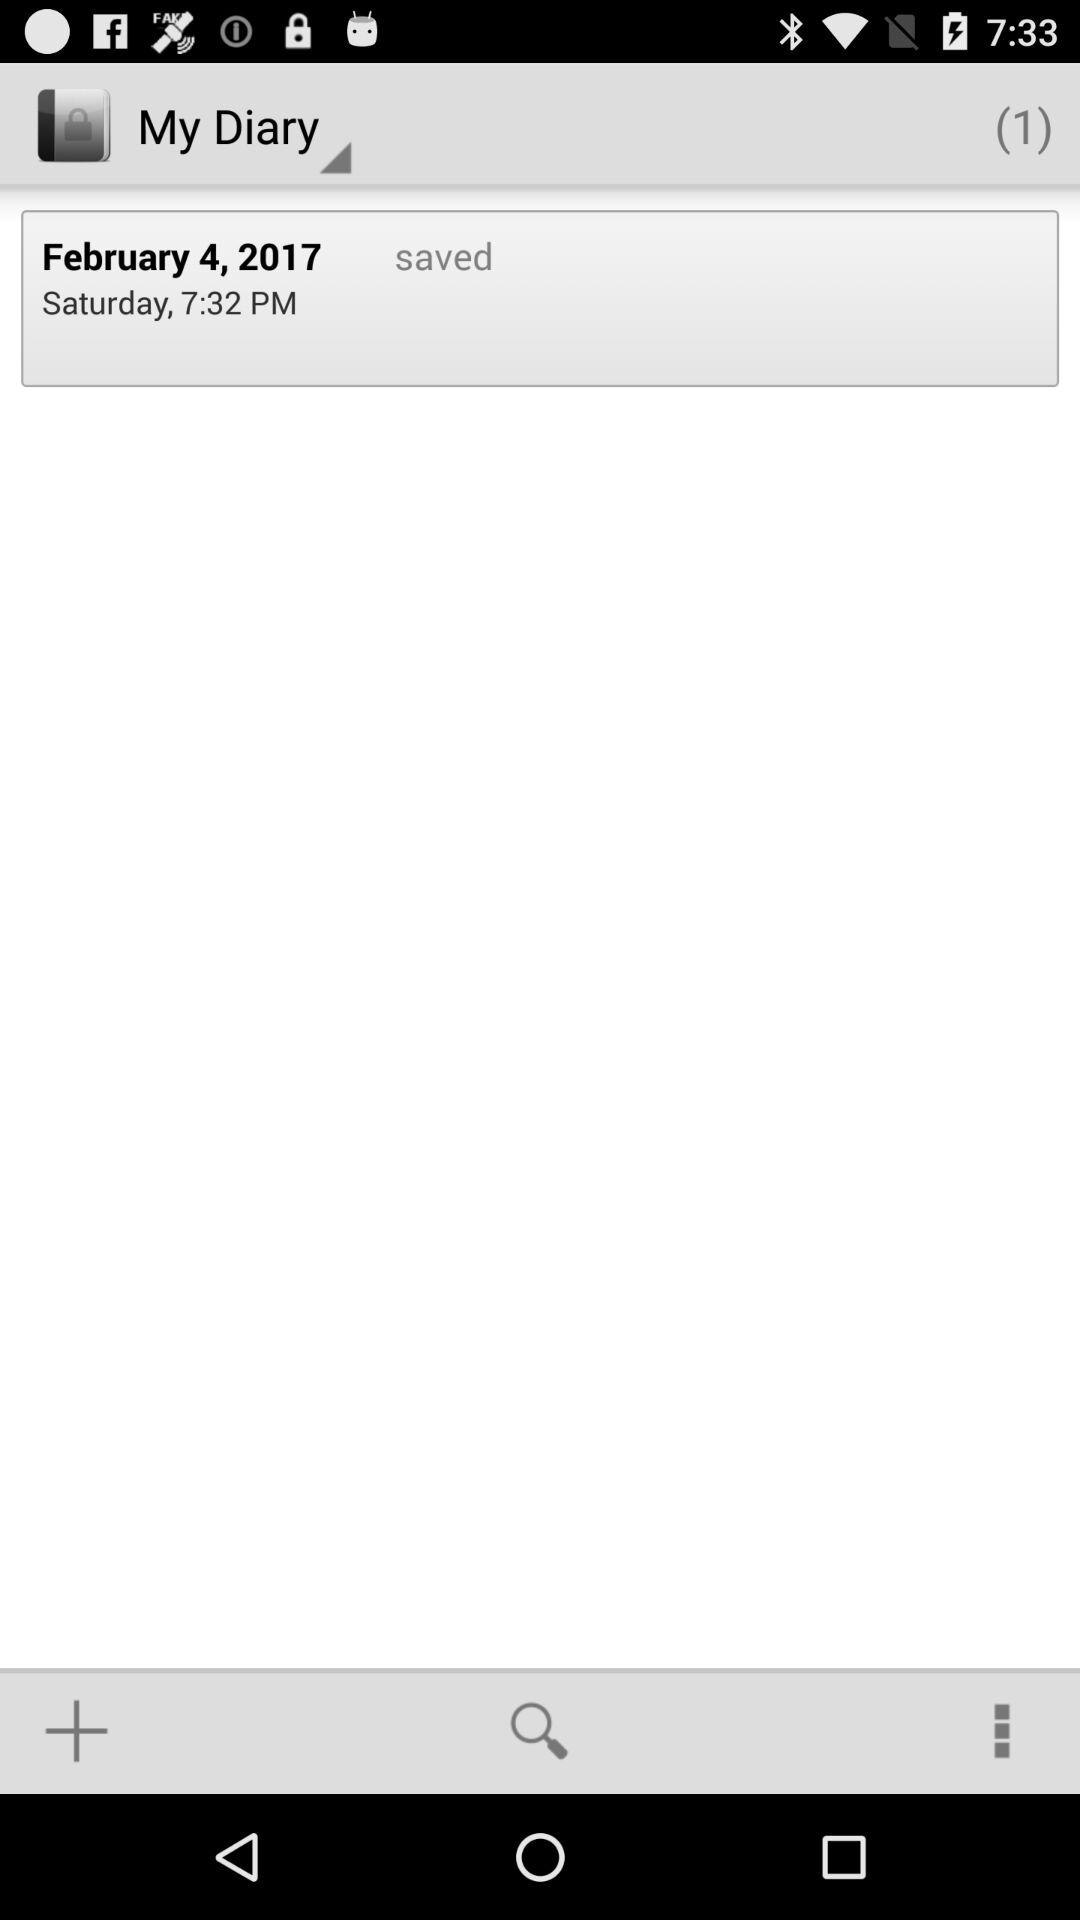What is the day of the selected date? The day is Saturday. 